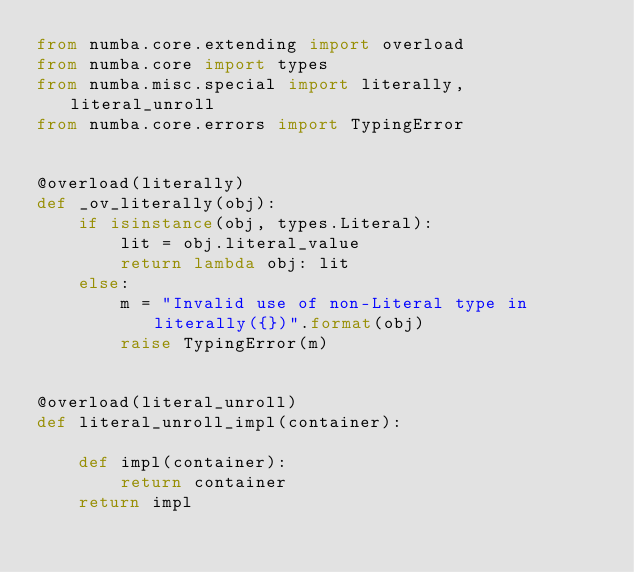Convert code to text. <code><loc_0><loc_0><loc_500><loc_500><_Python_>from numba.core.extending import overload
from numba.core import types
from numba.misc.special import literally, literal_unroll
from numba.core.errors import TypingError


@overload(literally)
def _ov_literally(obj):
    if isinstance(obj, types.Literal):
        lit = obj.literal_value
        return lambda obj: lit
    else:
        m = "Invalid use of non-Literal type in literally({})".format(obj)
        raise TypingError(m)


@overload(literal_unroll)
def literal_unroll_impl(container):

    def impl(container):
        return container
    return impl
</code> 